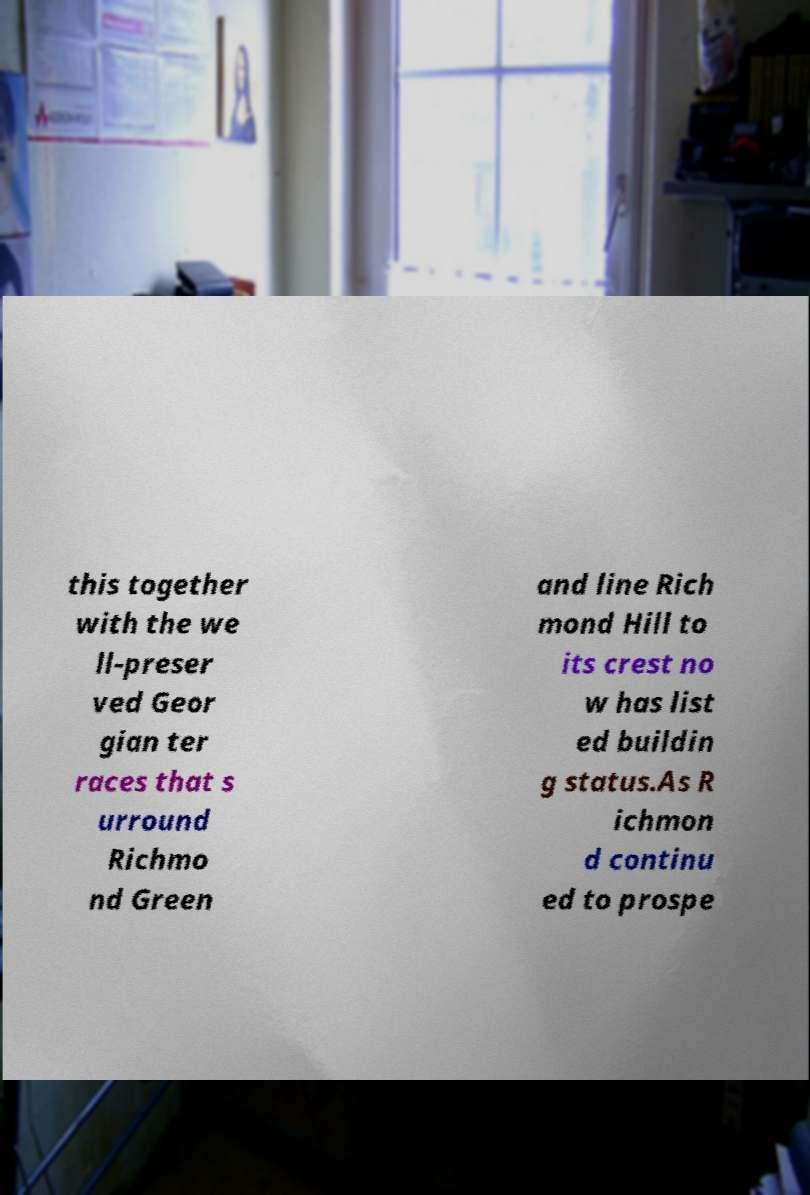Can you read and provide the text displayed in the image?This photo seems to have some interesting text. Can you extract and type it out for me? this together with the we ll-preser ved Geor gian ter races that s urround Richmo nd Green and line Rich mond Hill to its crest no w has list ed buildin g status.As R ichmon d continu ed to prospe 